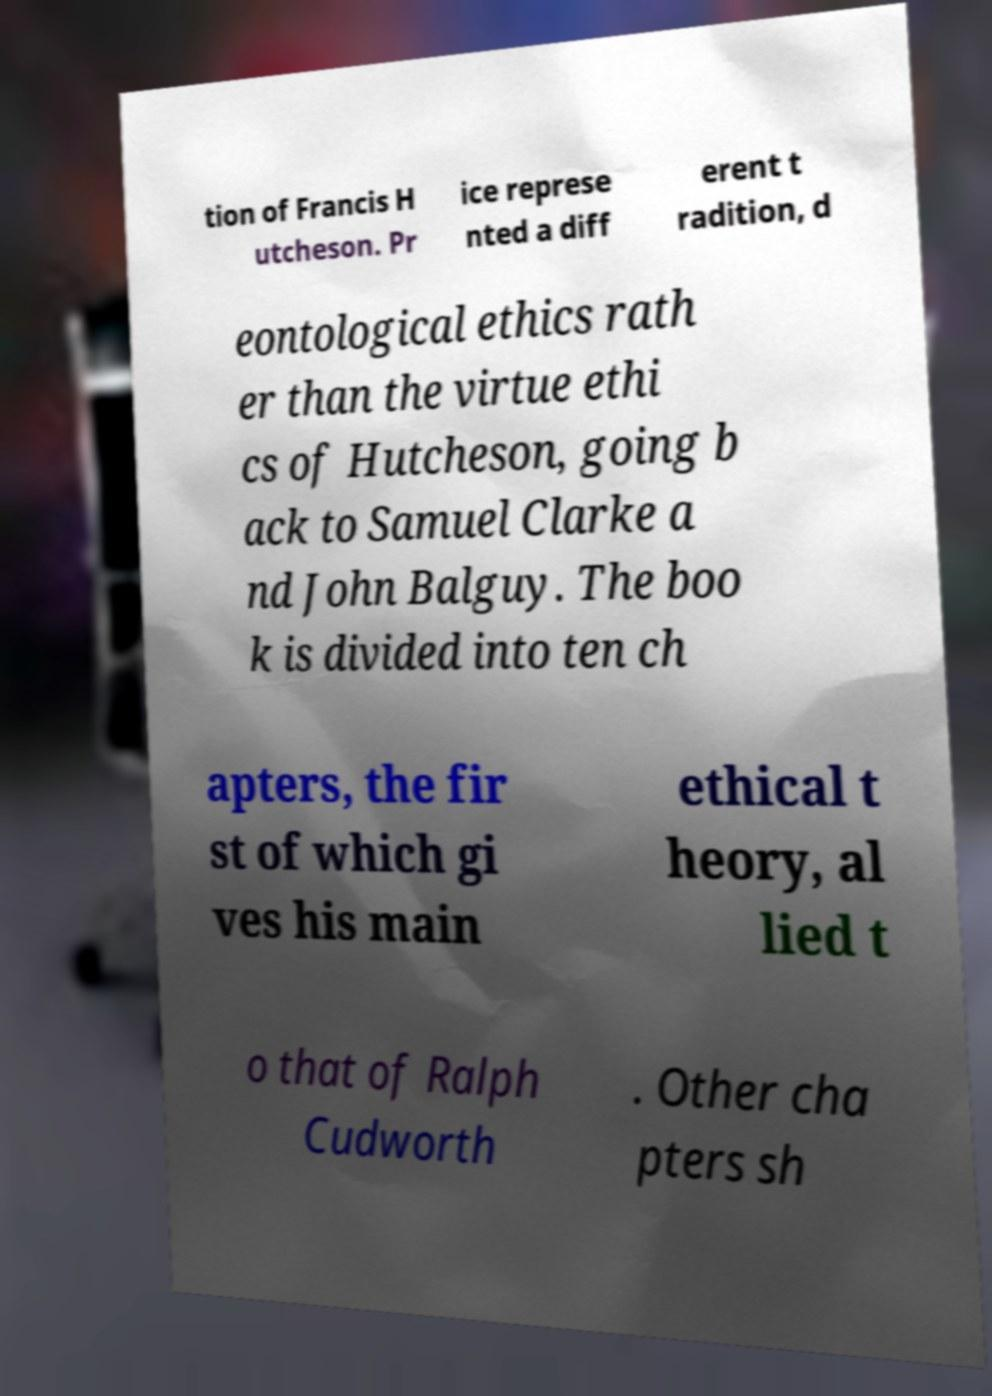I need the written content from this picture converted into text. Can you do that? tion of Francis H utcheson. Pr ice represe nted a diff erent t radition, d eontological ethics rath er than the virtue ethi cs of Hutcheson, going b ack to Samuel Clarke a nd John Balguy. The boo k is divided into ten ch apters, the fir st of which gi ves his main ethical t heory, al lied t o that of Ralph Cudworth . Other cha pters sh 